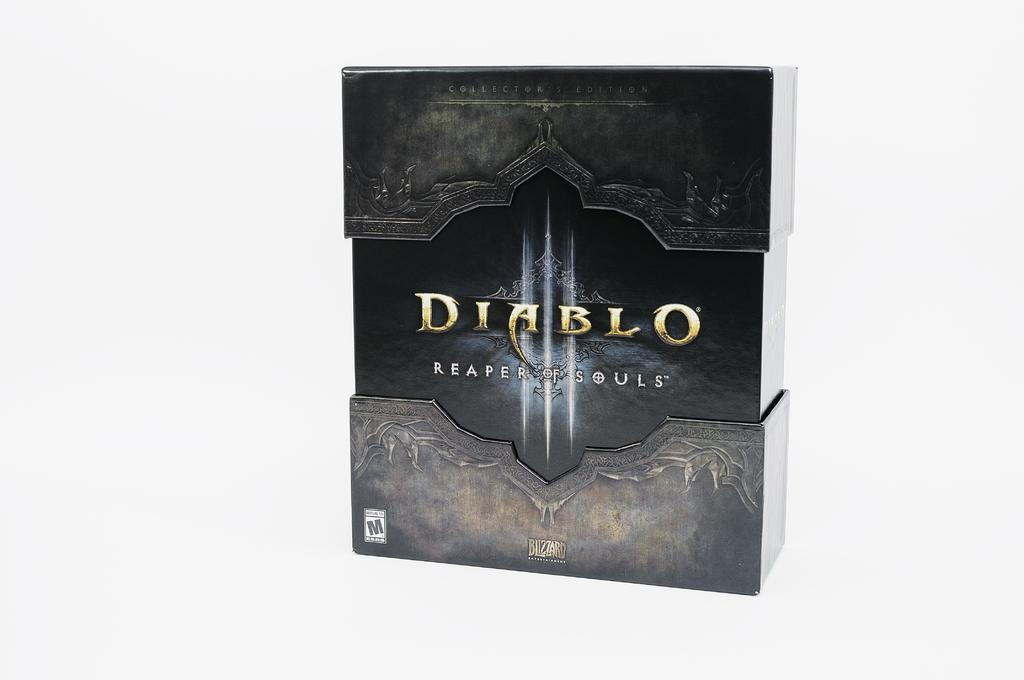What is the main object in the picture? There is a box in the picture. What color is the box? The box is black in color. What text is written on the box? The box has the text "DIABLO reaper of Reaper of Souls" written on it. Are there any designs on the box? Yes, there are designs on the box. Are there any cobwebs visible on the box in the image? There are no cobwebs present on the box in the image. What direction is the box facing in the image? The direction the box is facing cannot be determined from the image, as it is a static object. 